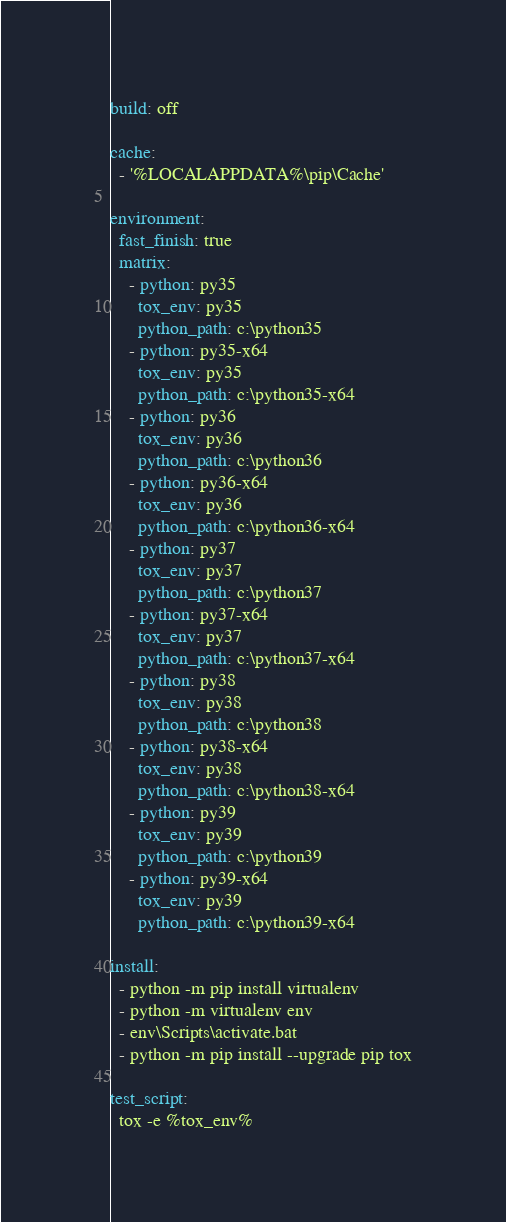Convert code to text. <code><loc_0><loc_0><loc_500><loc_500><_YAML_>build: off

cache:
  - '%LOCALAPPDATA%\pip\Cache'

environment:
  fast_finish: true
  matrix:
    - python: py35
      tox_env: py35
      python_path: c:\python35
    - python: py35-x64
      tox_env: py35
      python_path: c:\python35-x64
    - python: py36
      tox_env: py36
      python_path: c:\python36
    - python: py36-x64
      tox_env: py36
      python_path: c:\python36-x64
    - python: py37
      tox_env: py37
      python_path: c:\python37
    - python: py37-x64
      tox_env: py37
      python_path: c:\python37-x64
    - python: py38
      tox_env: py38
      python_path: c:\python38
    - python: py38-x64
      tox_env: py38
      python_path: c:\python38-x64
    - python: py39
      tox_env: py39
      python_path: c:\python39
    - python: py39-x64
      tox_env: py39
      python_path: c:\python39-x64

install:
  - python -m pip install virtualenv
  - python -m virtualenv env
  - env\Scripts\activate.bat
  - python -m pip install --upgrade pip tox

test_script:
  tox -e %tox_env%
</code> 